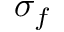Convert formula to latex. <formula><loc_0><loc_0><loc_500><loc_500>\sigma _ { f }</formula> 